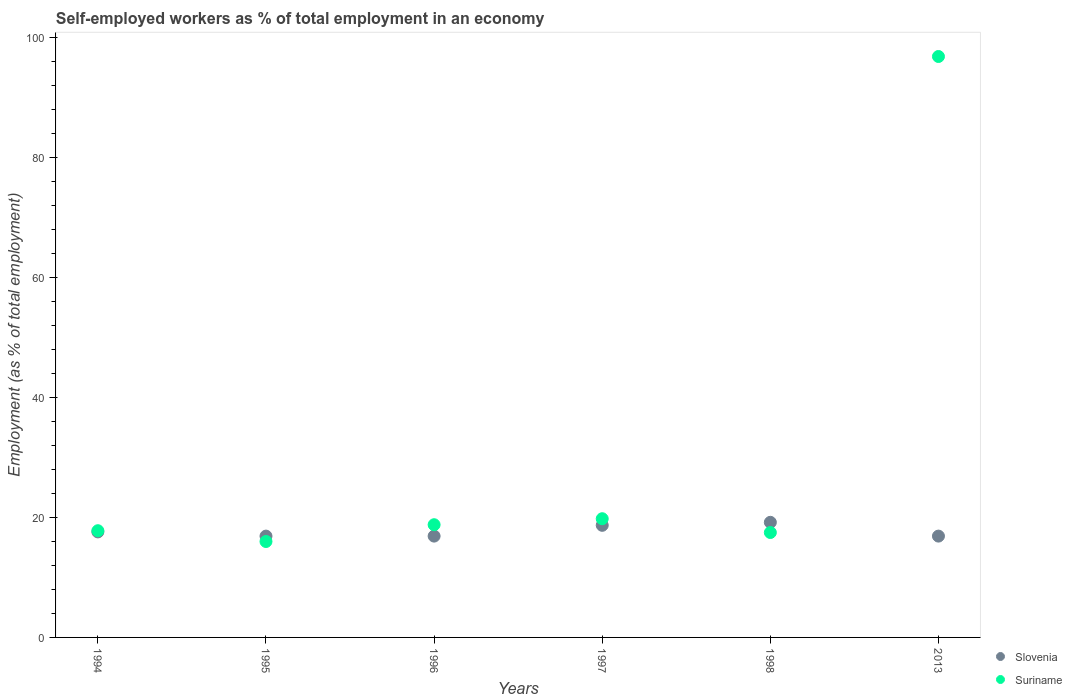Is the number of dotlines equal to the number of legend labels?
Your answer should be very brief. Yes. What is the percentage of self-employed workers in Slovenia in 1994?
Offer a very short reply. 17.6. Across all years, what is the maximum percentage of self-employed workers in Slovenia?
Make the answer very short. 19.2. Across all years, what is the minimum percentage of self-employed workers in Slovenia?
Offer a terse response. 16.9. In which year was the percentage of self-employed workers in Slovenia minimum?
Provide a short and direct response. 1995. What is the total percentage of self-employed workers in Suriname in the graph?
Give a very brief answer. 186.8. What is the difference between the percentage of self-employed workers in Suriname in 1997 and that in 2013?
Ensure brevity in your answer.  -77.1. What is the difference between the percentage of self-employed workers in Suriname in 1994 and the percentage of self-employed workers in Slovenia in 1995?
Provide a succinct answer. 0.9. What is the average percentage of self-employed workers in Slovenia per year?
Ensure brevity in your answer.  17.7. In the year 1997, what is the difference between the percentage of self-employed workers in Slovenia and percentage of self-employed workers in Suriname?
Offer a very short reply. -1.1. In how many years, is the percentage of self-employed workers in Suriname greater than 44 %?
Make the answer very short. 1. Is the percentage of self-employed workers in Slovenia in 1997 less than that in 2013?
Make the answer very short. No. Is the difference between the percentage of self-employed workers in Slovenia in 1994 and 1996 greater than the difference between the percentage of self-employed workers in Suriname in 1994 and 1996?
Offer a terse response. Yes. What is the difference between the highest and the second highest percentage of self-employed workers in Suriname?
Make the answer very short. 77.1. What is the difference between the highest and the lowest percentage of self-employed workers in Slovenia?
Your response must be concise. 2.3. In how many years, is the percentage of self-employed workers in Slovenia greater than the average percentage of self-employed workers in Slovenia taken over all years?
Offer a very short reply. 2. Is the sum of the percentage of self-employed workers in Slovenia in 1998 and 2013 greater than the maximum percentage of self-employed workers in Suriname across all years?
Keep it short and to the point. No. Is the percentage of self-employed workers in Suriname strictly greater than the percentage of self-employed workers in Slovenia over the years?
Your answer should be very brief. No. How many dotlines are there?
Your answer should be compact. 2. Are the values on the major ticks of Y-axis written in scientific E-notation?
Give a very brief answer. No. How are the legend labels stacked?
Make the answer very short. Vertical. What is the title of the graph?
Give a very brief answer. Self-employed workers as % of total employment in an economy. What is the label or title of the X-axis?
Your response must be concise. Years. What is the label or title of the Y-axis?
Give a very brief answer. Employment (as % of total employment). What is the Employment (as % of total employment) in Slovenia in 1994?
Keep it short and to the point. 17.6. What is the Employment (as % of total employment) in Suriname in 1994?
Give a very brief answer. 17.8. What is the Employment (as % of total employment) of Slovenia in 1995?
Your answer should be very brief. 16.9. What is the Employment (as % of total employment) in Suriname in 1995?
Provide a succinct answer. 16. What is the Employment (as % of total employment) in Slovenia in 1996?
Your response must be concise. 16.9. What is the Employment (as % of total employment) of Suriname in 1996?
Your answer should be very brief. 18.8. What is the Employment (as % of total employment) of Slovenia in 1997?
Keep it short and to the point. 18.7. What is the Employment (as % of total employment) in Suriname in 1997?
Make the answer very short. 19.8. What is the Employment (as % of total employment) in Slovenia in 1998?
Offer a terse response. 19.2. What is the Employment (as % of total employment) of Slovenia in 2013?
Make the answer very short. 16.9. What is the Employment (as % of total employment) of Suriname in 2013?
Your answer should be very brief. 96.9. Across all years, what is the maximum Employment (as % of total employment) of Slovenia?
Provide a short and direct response. 19.2. Across all years, what is the maximum Employment (as % of total employment) of Suriname?
Your answer should be very brief. 96.9. Across all years, what is the minimum Employment (as % of total employment) of Slovenia?
Give a very brief answer. 16.9. Across all years, what is the minimum Employment (as % of total employment) of Suriname?
Your answer should be very brief. 16. What is the total Employment (as % of total employment) in Slovenia in the graph?
Your answer should be very brief. 106.2. What is the total Employment (as % of total employment) of Suriname in the graph?
Offer a very short reply. 186.8. What is the difference between the Employment (as % of total employment) in Slovenia in 1994 and that in 1995?
Provide a short and direct response. 0.7. What is the difference between the Employment (as % of total employment) of Slovenia in 1994 and that in 1998?
Give a very brief answer. -1.6. What is the difference between the Employment (as % of total employment) of Slovenia in 1994 and that in 2013?
Give a very brief answer. 0.7. What is the difference between the Employment (as % of total employment) of Suriname in 1994 and that in 2013?
Provide a short and direct response. -79.1. What is the difference between the Employment (as % of total employment) in Suriname in 1995 and that in 1997?
Make the answer very short. -3.8. What is the difference between the Employment (as % of total employment) of Slovenia in 1995 and that in 1998?
Your answer should be compact. -2.3. What is the difference between the Employment (as % of total employment) in Suriname in 1995 and that in 1998?
Your answer should be compact. -1.5. What is the difference between the Employment (as % of total employment) in Slovenia in 1995 and that in 2013?
Make the answer very short. 0. What is the difference between the Employment (as % of total employment) of Suriname in 1995 and that in 2013?
Ensure brevity in your answer.  -80.9. What is the difference between the Employment (as % of total employment) in Slovenia in 1996 and that in 1998?
Ensure brevity in your answer.  -2.3. What is the difference between the Employment (as % of total employment) of Slovenia in 1996 and that in 2013?
Offer a terse response. 0. What is the difference between the Employment (as % of total employment) of Suriname in 1996 and that in 2013?
Give a very brief answer. -78.1. What is the difference between the Employment (as % of total employment) of Slovenia in 1997 and that in 1998?
Make the answer very short. -0.5. What is the difference between the Employment (as % of total employment) in Suriname in 1997 and that in 2013?
Your answer should be compact. -77.1. What is the difference between the Employment (as % of total employment) of Suriname in 1998 and that in 2013?
Make the answer very short. -79.4. What is the difference between the Employment (as % of total employment) in Slovenia in 1994 and the Employment (as % of total employment) in Suriname in 1995?
Provide a succinct answer. 1.6. What is the difference between the Employment (as % of total employment) in Slovenia in 1994 and the Employment (as % of total employment) in Suriname in 1996?
Provide a short and direct response. -1.2. What is the difference between the Employment (as % of total employment) of Slovenia in 1994 and the Employment (as % of total employment) of Suriname in 1997?
Your answer should be compact. -2.2. What is the difference between the Employment (as % of total employment) of Slovenia in 1994 and the Employment (as % of total employment) of Suriname in 2013?
Your response must be concise. -79.3. What is the difference between the Employment (as % of total employment) of Slovenia in 1995 and the Employment (as % of total employment) of Suriname in 1998?
Make the answer very short. -0.6. What is the difference between the Employment (as % of total employment) in Slovenia in 1995 and the Employment (as % of total employment) in Suriname in 2013?
Provide a short and direct response. -80. What is the difference between the Employment (as % of total employment) in Slovenia in 1996 and the Employment (as % of total employment) in Suriname in 1998?
Provide a succinct answer. -0.6. What is the difference between the Employment (as % of total employment) in Slovenia in 1996 and the Employment (as % of total employment) in Suriname in 2013?
Provide a succinct answer. -80. What is the difference between the Employment (as % of total employment) of Slovenia in 1997 and the Employment (as % of total employment) of Suriname in 1998?
Ensure brevity in your answer.  1.2. What is the difference between the Employment (as % of total employment) in Slovenia in 1997 and the Employment (as % of total employment) in Suriname in 2013?
Offer a very short reply. -78.2. What is the difference between the Employment (as % of total employment) in Slovenia in 1998 and the Employment (as % of total employment) in Suriname in 2013?
Your response must be concise. -77.7. What is the average Employment (as % of total employment) of Slovenia per year?
Give a very brief answer. 17.7. What is the average Employment (as % of total employment) in Suriname per year?
Offer a very short reply. 31.13. In the year 1995, what is the difference between the Employment (as % of total employment) in Slovenia and Employment (as % of total employment) in Suriname?
Make the answer very short. 0.9. In the year 1996, what is the difference between the Employment (as % of total employment) of Slovenia and Employment (as % of total employment) of Suriname?
Provide a short and direct response. -1.9. In the year 1997, what is the difference between the Employment (as % of total employment) in Slovenia and Employment (as % of total employment) in Suriname?
Offer a very short reply. -1.1. In the year 2013, what is the difference between the Employment (as % of total employment) of Slovenia and Employment (as % of total employment) of Suriname?
Your answer should be compact. -80. What is the ratio of the Employment (as % of total employment) in Slovenia in 1994 to that in 1995?
Your answer should be compact. 1.04. What is the ratio of the Employment (as % of total employment) in Suriname in 1994 to that in 1995?
Your answer should be very brief. 1.11. What is the ratio of the Employment (as % of total employment) of Slovenia in 1994 to that in 1996?
Provide a short and direct response. 1.04. What is the ratio of the Employment (as % of total employment) in Suriname in 1994 to that in 1996?
Your response must be concise. 0.95. What is the ratio of the Employment (as % of total employment) of Slovenia in 1994 to that in 1997?
Offer a terse response. 0.94. What is the ratio of the Employment (as % of total employment) of Suriname in 1994 to that in 1997?
Your answer should be very brief. 0.9. What is the ratio of the Employment (as % of total employment) in Suriname in 1994 to that in 1998?
Provide a succinct answer. 1.02. What is the ratio of the Employment (as % of total employment) of Slovenia in 1994 to that in 2013?
Make the answer very short. 1.04. What is the ratio of the Employment (as % of total employment) in Suriname in 1994 to that in 2013?
Your answer should be compact. 0.18. What is the ratio of the Employment (as % of total employment) of Suriname in 1995 to that in 1996?
Give a very brief answer. 0.85. What is the ratio of the Employment (as % of total employment) in Slovenia in 1995 to that in 1997?
Provide a short and direct response. 0.9. What is the ratio of the Employment (as % of total employment) of Suriname in 1995 to that in 1997?
Provide a succinct answer. 0.81. What is the ratio of the Employment (as % of total employment) of Slovenia in 1995 to that in 1998?
Provide a succinct answer. 0.88. What is the ratio of the Employment (as % of total employment) of Suriname in 1995 to that in 1998?
Give a very brief answer. 0.91. What is the ratio of the Employment (as % of total employment) in Slovenia in 1995 to that in 2013?
Your response must be concise. 1. What is the ratio of the Employment (as % of total employment) of Suriname in 1995 to that in 2013?
Make the answer very short. 0.17. What is the ratio of the Employment (as % of total employment) of Slovenia in 1996 to that in 1997?
Ensure brevity in your answer.  0.9. What is the ratio of the Employment (as % of total employment) of Suriname in 1996 to that in 1997?
Your answer should be very brief. 0.95. What is the ratio of the Employment (as % of total employment) in Slovenia in 1996 to that in 1998?
Your answer should be very brief. 0.88. What is the ratio of the Employment (as % of total employment) in Suriname in 1996 to that in 1998?
Keep it short and to the point. 1.07. What is the ratio of the Employment (as % of total employment) in Suriname in 1996 to that in 2013?
Provide a short and direct response. 0.19. What is the ratio of the Employment (as % of total employment) in Suriname in 1997 to that in 1998?
Your answer should be compact. 1.13. What is the ratio of the Employment (as % of total employment) in Slovenia in 1997 to that in 2013?
Your response must be concise. 1.11. What is the ratio of the Employment (as % of total employment) of Suriname in 1997 to that in 2013?
Keep it short and to the point. 0.2. What is the ratio of the Employment (as % of total employment) in Slovenia in 1998 to that in 2013?
Keep it short and to the point. 1.14. What is the ratio of the Employment (as % of total employment) of Suriname in 1998 to that in 2013?
Give a very brief answer. 0.18. What is the difference between the highest and the second highest Employment (as % of total employment) of Slovenia?
Make the answer very short. 0.5. What is the difference between the highest and the second highest Employment (as % of total employment) of Suriname?
Provide a succinct answer. 77.1. What is the difference between the highest and the lowest Employment (as % of total employment) in Suriname?
Ensure brevity in your answer.  80.9. 